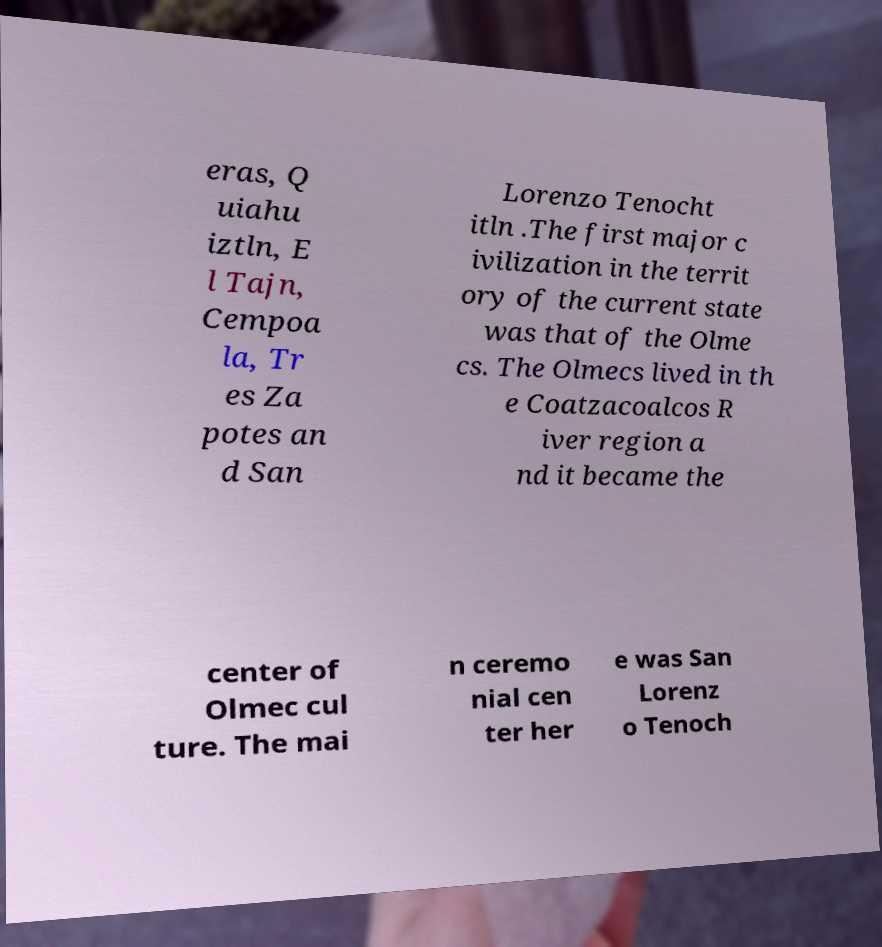Could you extract and type out the text from this image? eras, Q uiahu iztln, E l Tajn, Cempoa la, Tr es Za potes an d San Lorenzo Tenocht itln .The first major c ivilization in the territ ory of the current state was that of the Olme cs. The Olmecs lived in th e Coatzacoalcos R iver region a nd it became the center of Olmec cul ture. The mai n ceremo nial cen ter her e was San Lorenz o Tenoch 